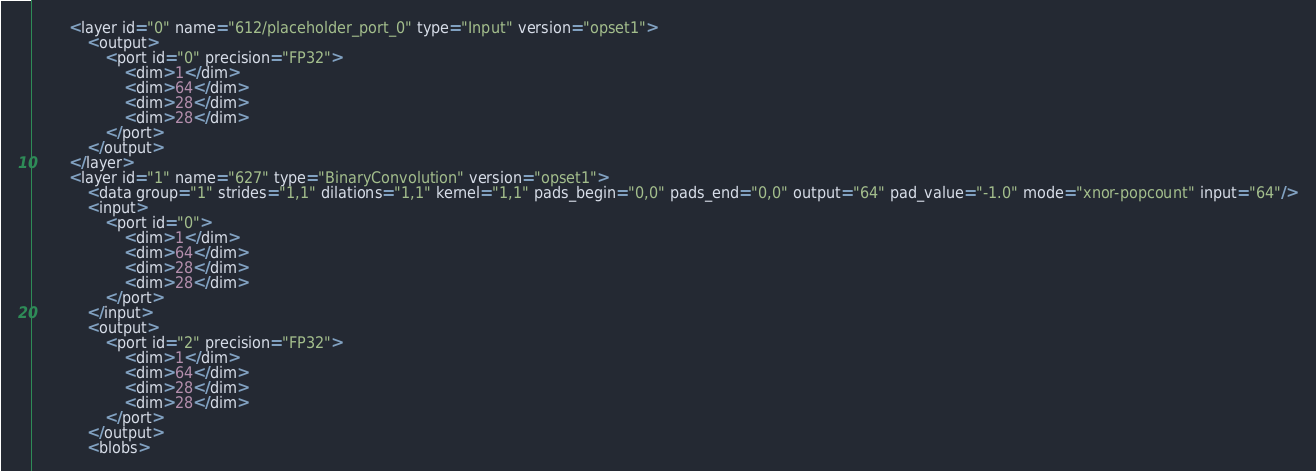<code> <loc_0><loc_0><loc_500><loc_500><_C++_>		<layer id="0" name="612/placeholder_port_0" type="Input" version="opset1">
			<output>
				<port id="0" precision="FP32">
					<dim>1</dim>
					<dim>64</dim>
					<dim>28</dim>
					<dim>28</dim>
				</port>
			</output>
		</layer>
		<layer id="1" name="627" type="BinaryConvolution" version="opset1">
			<data group="1" strides="1,1" dilations="1,1" kernel="1,1" pads_begin="0,0" pads_end="0,0" output="64" pad_value="-1.0" mode="xnor-popcount" input="64"/>
			<input>
				<port id="0">
					<dim>1</dim>
					<dim>64</dim>
					<dim>28</dim>
					<dim>28</dim>
				</port>
			</input>
			<output>
				<port id="2" precision="FP32">
					<dim>1</dim>
					<dim>64</dim>
					<dim>28</dim>
					<dim>28</dim>
				</port>
			</output>
			<blobs></code> 